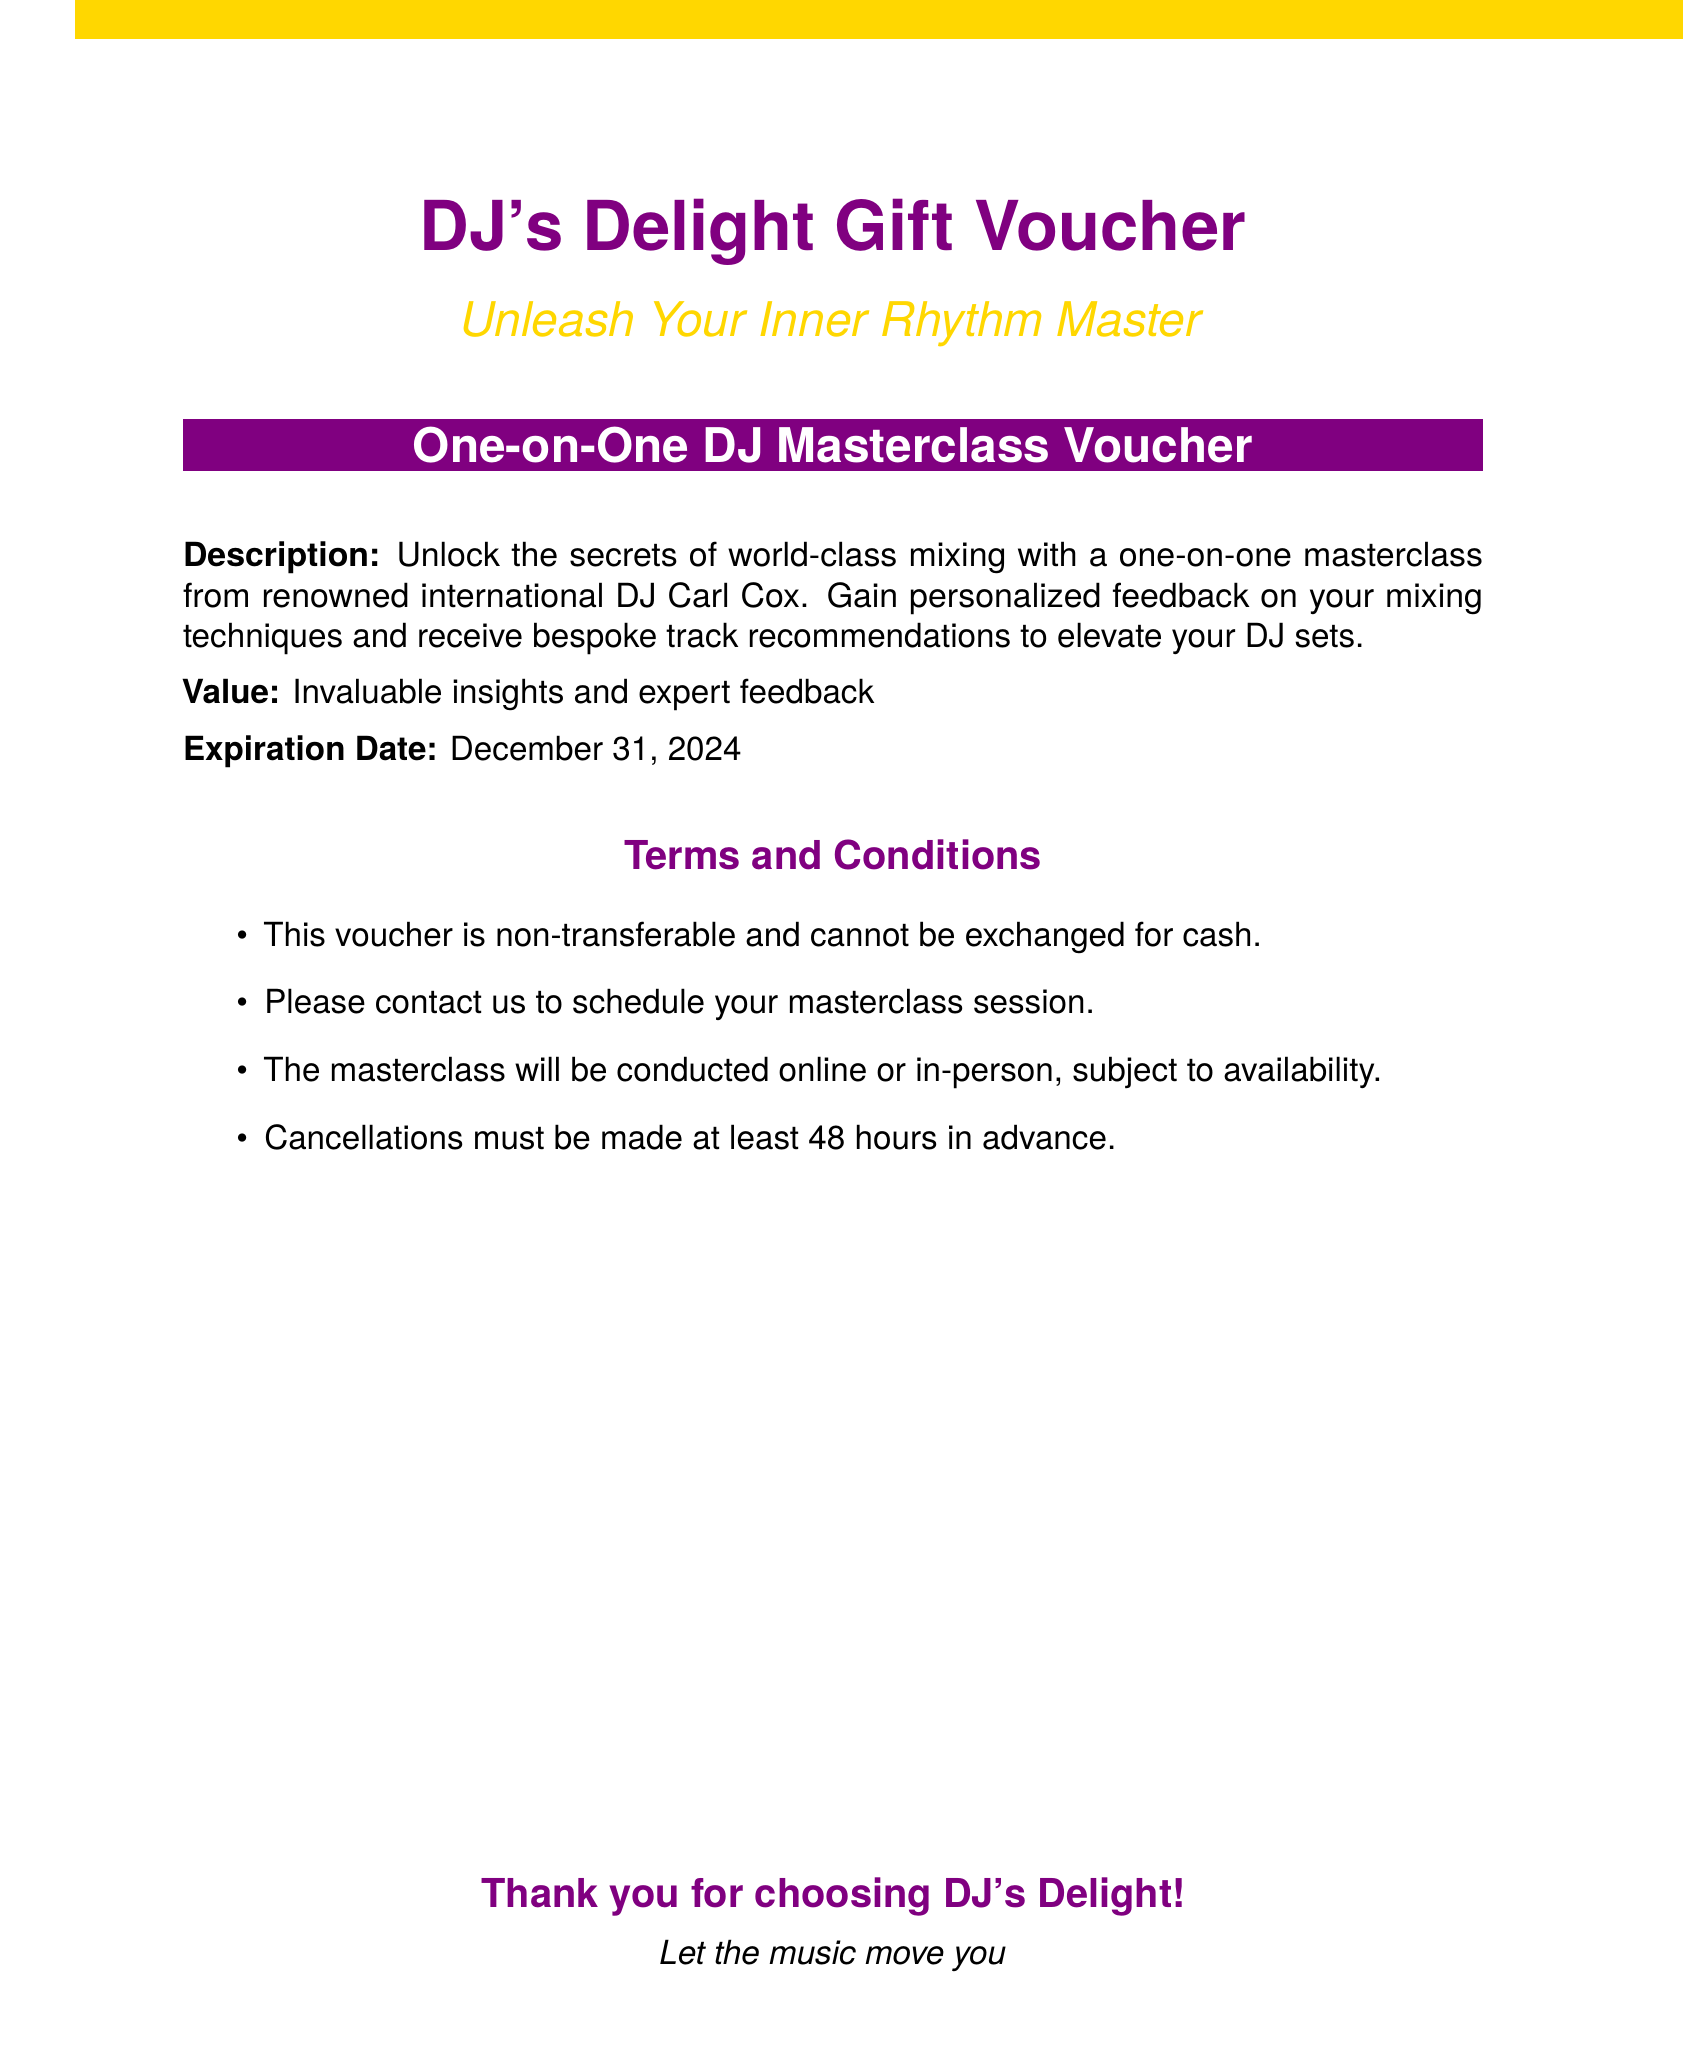What is the name of the DJ offering the masterclass? The document specifies that renowned international DJ Carl Cox will be conducting the masterclass.
Answer: Carl Cox What is the value provided by the masterclass voucher? The document states that the masterclass provides invaluable insights and expert feedback.
Answer: Invaluable insights and expert feedback What is the expiration date of the voucher? The document indicates that the voucher expires on December 31, 2024.
Answer: December 31, 2024 Are there any conditions for cancelling the masterclass session? The document mentions that cancellations must be made at least 48 hours in advance.
Answer: 48 hours What type of class is included in the voucher? The document clearly describes the offering as a one-on-one DJ masterclass.
Answer: One-on-one DJ masterclass Is this voucher transferable? The terms state that this voucher is non-transferable and cannot be exchanged for cash.
Answer: Non-transferable How can one schedule the masterclass session? The document instructs that one must contact to schedule the masterclass session.
Answer: Contact us What is the theme of the gift voucher? The theme of the gift voucher is to unleash the inner rhythm master, as stated in the document.
Answer: Unleash Your Inner Rhythm Master 